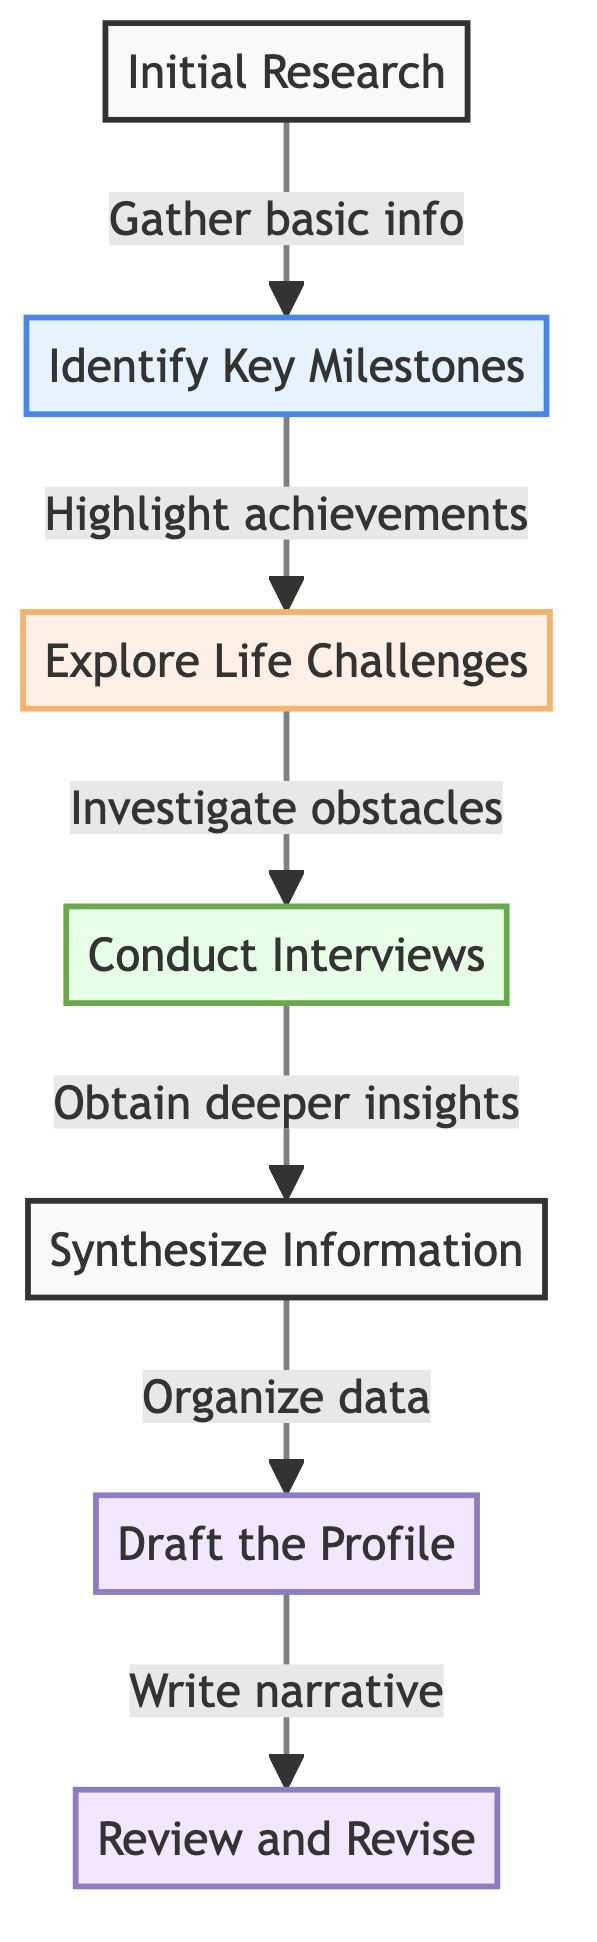What is the first step in the process? The diagram indicates that the first step in the process is "Initial Research," which is the starting point for gathering information.
Answer: Initial Research How many steps are there in total? Counting all the steps listed in the diagram, there are seven steps that outline the process for creating a personal profile.
Answer: 7 What is the relationship between "Identify Key Milestones" and "Explore Life Challenges"? In the flow chart, "Identify Key Milestones" leads directly to "Explore Life Challenges," indicating that after recognizing key achievements, the next step is to investigate challenges faced by the subject.
Answer: Leads to What is the last step in the flow? The final step outlined in the flow chart is "Review and Revise," which concludes the process of creating a personal profile after drafting it.
Answer: Review and Revise What type of information is gathered in the "Initial Research" step? The "Initial Research" step focuses on gathering basic information about the subject's early years and family background, forming the foundation for further exploration.
Answer: Basic information Which step comes after "Conduct Interviews"? "Conduct Interviews" is followed by "Synthesize Information," highlighting the progression from obtaining insights to organizing data.
Answer: Synthesize Information How many milestone steps are present? There is one designated milestone step known as "Identify Key Milestones," reflecting the key achievements in the subject's life.
Answer: 1 What main actions does the "Draft the Profile" step entail? In the "Draft the Profile" step, the main action involves writing a narrative that captures the essence of the subject's background, milestones, challenges, and insights.
Answer: Write a narrative Which type of step is "Explore Life Challenges"? The step "Explore Life Challenges" is classified as a challenge step, indicating it addresses obstacles and struggles faced by the subject throughout their life.
Answer: Challenge step 